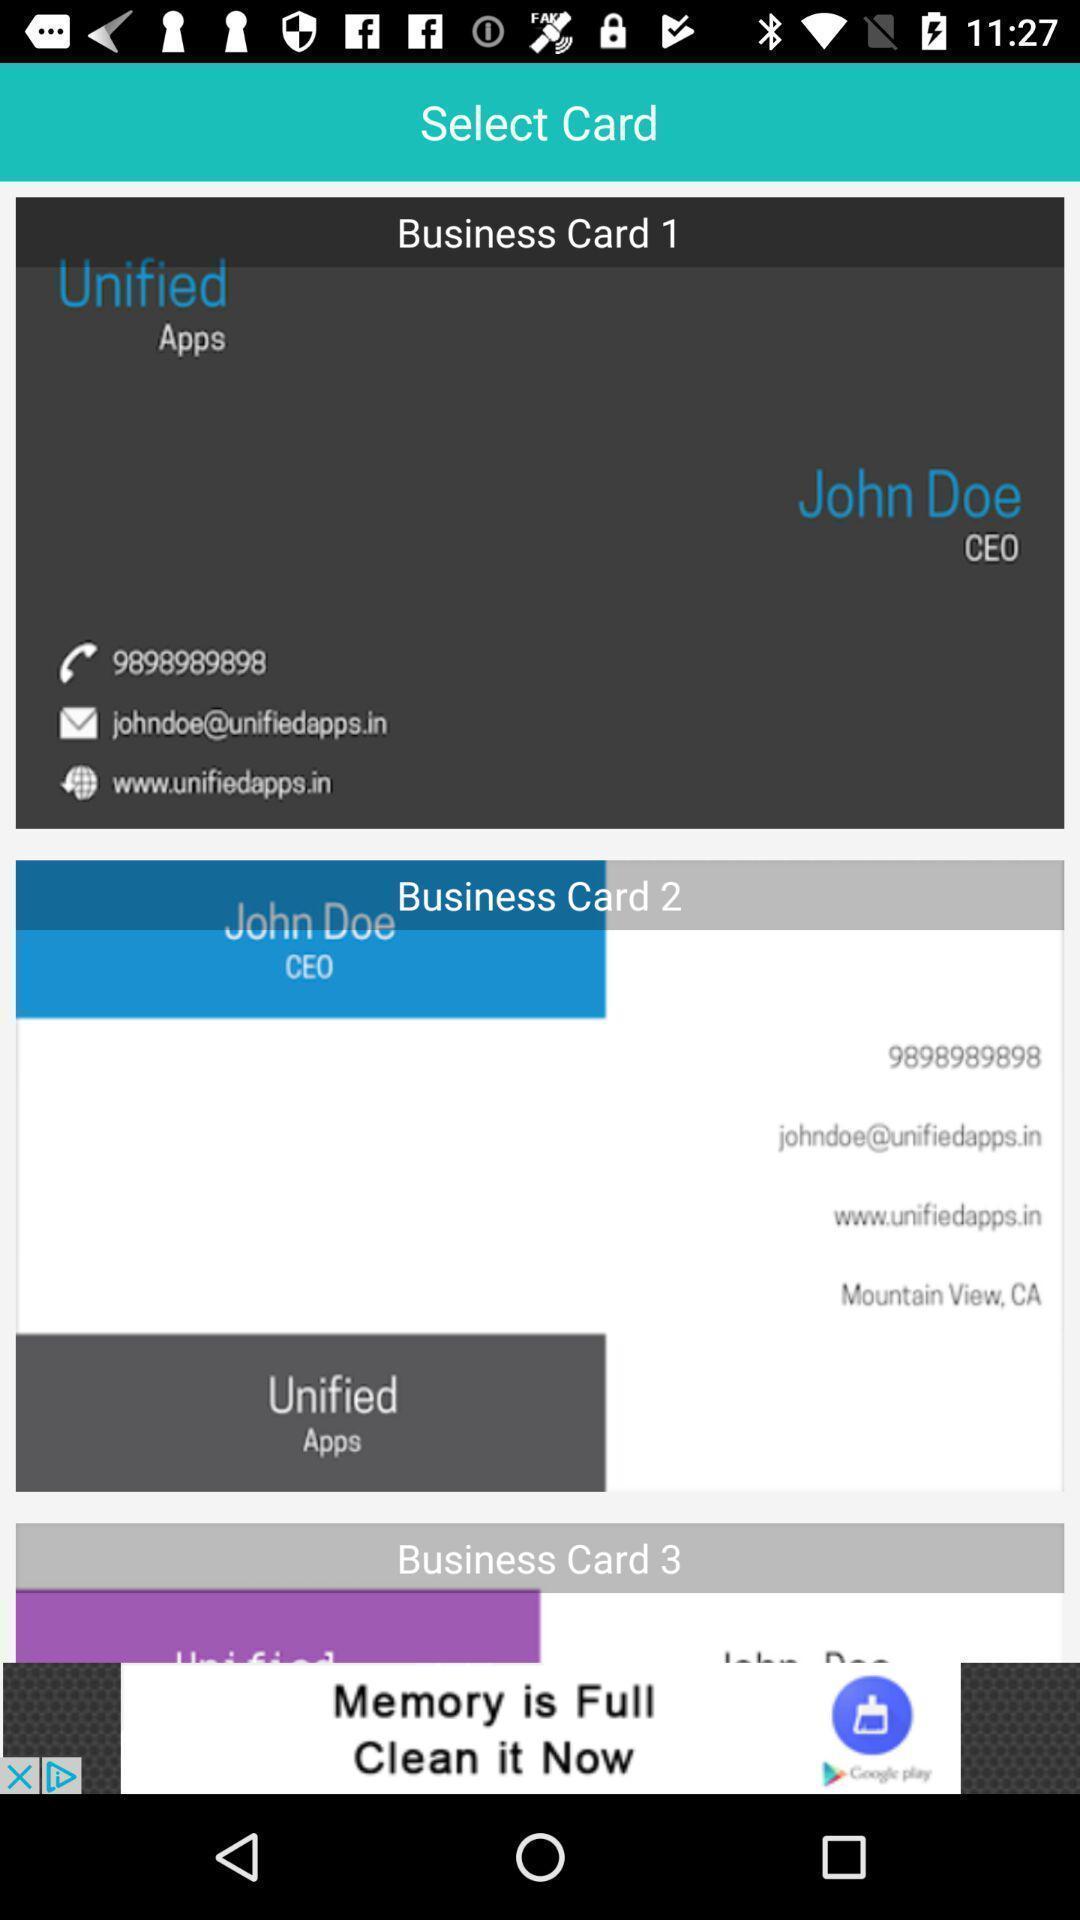Give me a summary of this screen capture. Screen displaying the card details. 